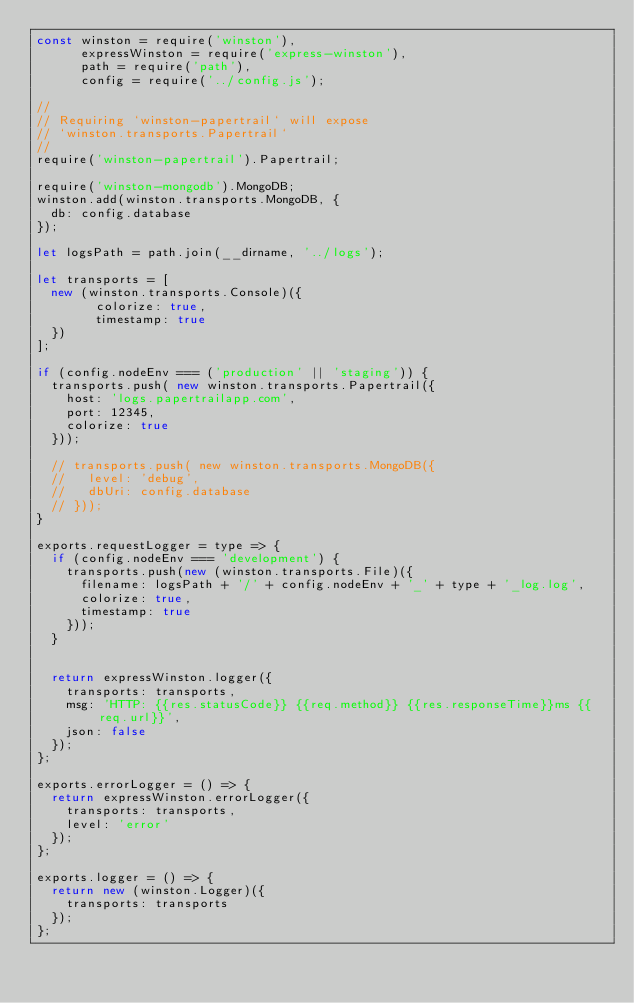<code> <loc_0><loc_0><loc_500><loc_500><_JavaScript_>const winston = require('winston'),
      expressWinston = require('express-winston'),
      path = require('path'),
      config = require('../config.js');

//
// Requiring `winston-papertrail` will expose
// `winston.transports.Papertrail`
//
require('winston-papertrail').Papertrail;

require('winston-mongodb').MongoDB;
winston.add(winston.transports.MongoDB, {
  db: config.database
});

let logsPath = path.join(__dirname, '../logs');

let transports = [
  new (winston.transports.Console)({
        colorize: true,
        timestamp: true
  })
];

if (config.nodeEnv === ('production' || 'staging')) {
  transports.push( new winston.transports.Papertrail({
    host: 'logs.papertrailapp.com',
    port: 12345,
    colorize: true
  }));

  // transports.push( new winston.transports.MongoDB({
  //   level: 'debug',
  //   dbUri: config.database
  // }));
}

exports.requestLogger = type => {
  if (config.nodeEnv === 'development') {
    transports.push(new (winston.transports.File)({
      filename: logsPath + '/' + config.nodeEnv + '_' + type + '_log.log',
      colorize: true,
      timestamp: true
    }));
  }
  

  return expressWinston.logger({
    transports: transports,
    msg: 'HTTP: {{res.statusCode}} {{req.method}} {{res.responseTime}}ms {{req.url}}',
    json: false
  });
};

exports.errorLogger = () => {
  return expressWinston.errorLogger({
    transports: transports,
    level: 'error'
  });
};

exports.logger = () => {
  return new (winston.Logger)({
    transports: transports
  });
};</code> 